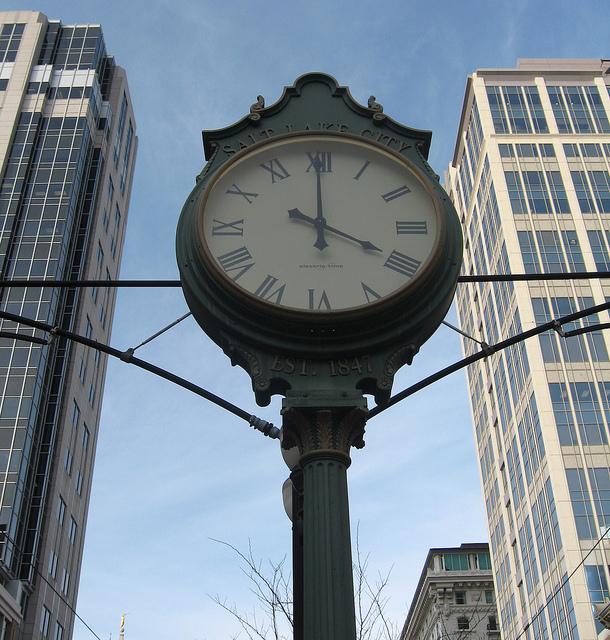What time is it?
Quick response, please. 4:00. How is the clock also a landmark?
Keep it brief. It stands out. What color is the clock?
Give a very brief answer. Green. 